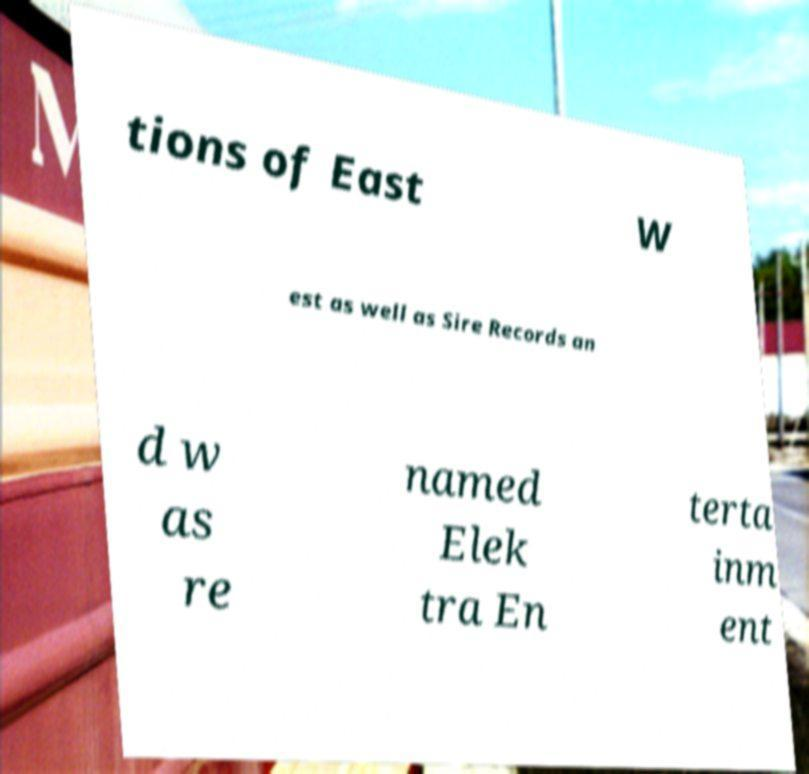For documentation purposes, I need the text within this image transcribed. Could you provide that? tions of East W est as well as Sire Records an d w as re named Elek tra En terta inm ent 